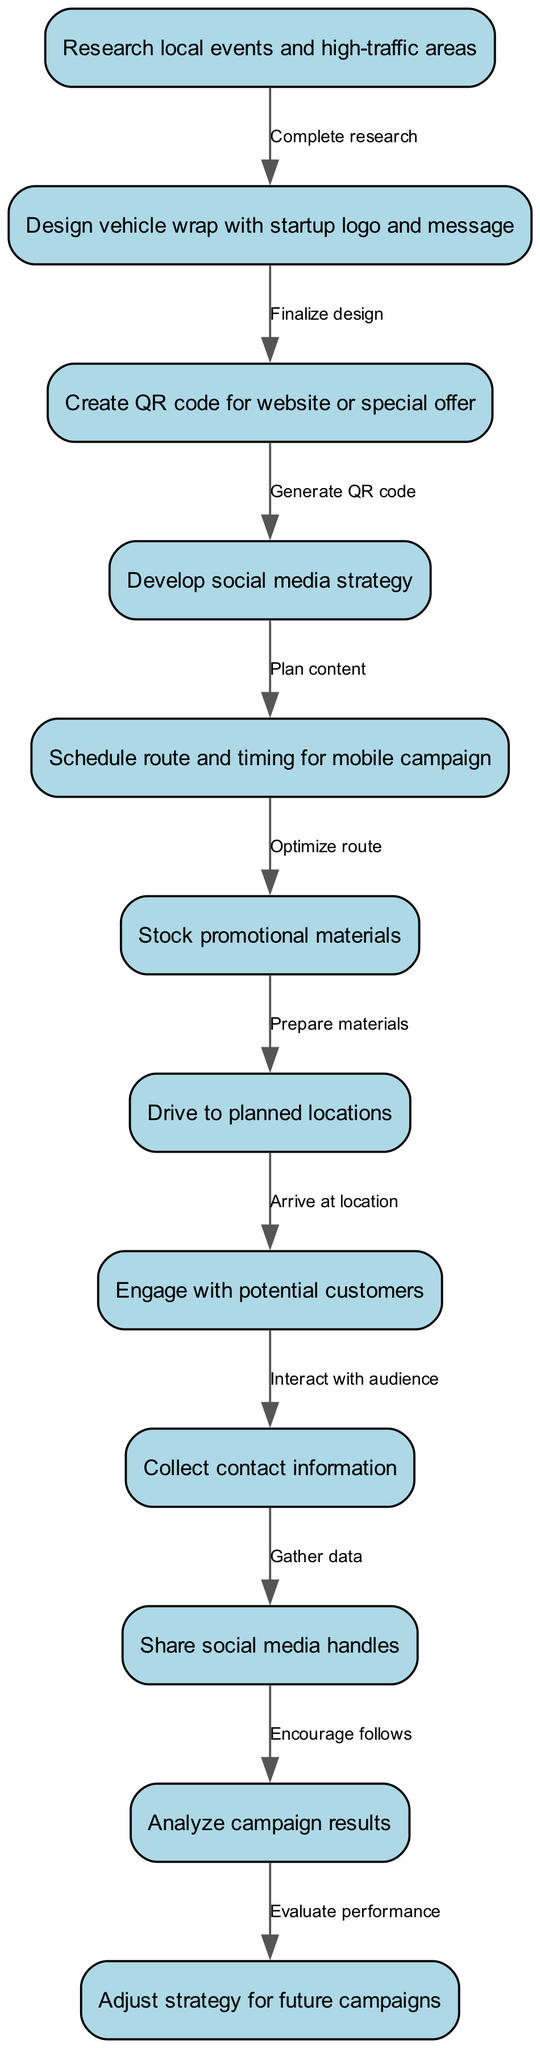What is the first action in the mobile marketing campaign? The first action listed in the diagram is "Research local events and high-traffic areas," which indicates the initial step of gathering information needed for the campaign.
Answer: Research local events and high-traffic areas How many nodes are included in the diagram? By counting all the unique actions represented in the nodes, there are a total of 12 nodes in the diagram.
Answer: 12 What action comes after designing the vehicle wrap? The action that comes immediately after "Design vehicle wrap with startup logo and message" is "Create QR code for website or special offer," showing the sequential flow of the campaign setup.
Answer: Create QR code for website or special offer What is the last action in the mobile marketing campaign process? The final action in the flow is "Adjust strategy for future campaigns," indicating a focus on continuous improvement after analyzing the results.
Answer: Adjust strategy for future campaigns Which two actions are directly linked by an edge that highlights social media engagement? The actions linked by this edge are "Engage with potential customers" and "Share social media handles," illustrating the interactive nature of the campaign.
Answer: Engage with potential customers and Share social media handles How many edges are present in the diagram? The total number of edges in the diagram can be determined by counting the connections between nodes, resulting in 11 edges that represent the flow of the campaign.
Answer: 11 What action follows collecting contact information? The action that directly follows "Collect contact information" is "Share social media handles," emphasizing the progression from collecting data to promoting social media engagement.
Answer: Share social media handles Which two nodes depict the analysis phase of the campaign? The nodes that represent the analysis phase are "Analyze campaign results" and "Adjust strategy for future campaigns," indicating the evaluation and improvement stage of the process.
Answer: Analyze campaign results and Adjust strategy for future campaigns What type of diagram is represented by this flow? The type of diagram represented is an Activity Diagram, which illustrates the sequential flow of actions within a process.
Answer: Activity Diagram 